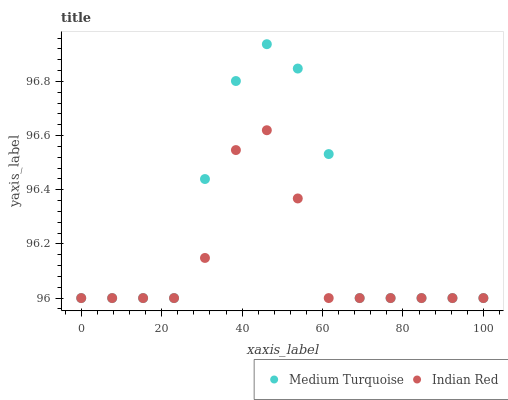Does Indian Red have the minimum area under the curve?
Answer yes or no. Yes. Does Medium Turquoise have the maximum area under the curve?
Answer yes or no. Yes. Does Medium Turquoise have the minimum area under the curve?
Answer yes or no. No. Is Indian Red the smoothest?
Answer yes or no. Yes. Is Medium Turquoise the roughest?
Answer yes or no. Yes. Is Medium Turquoise the smoothest?
Answer yes or no. No. Does Indian Red have the lowest value?
Answer yes or no. Yes. Does Medium Turquoise have the highest value?
Answer yes or no. Yes. Does Indian Red intersect Medium Turquoise?
Answer yes or no. Yes. Is Indian Red less than Medium Turquoise?
Answer yes or no. No. Is Indian Red greater than Medium Turquoise?
Answer yes or no. No. 